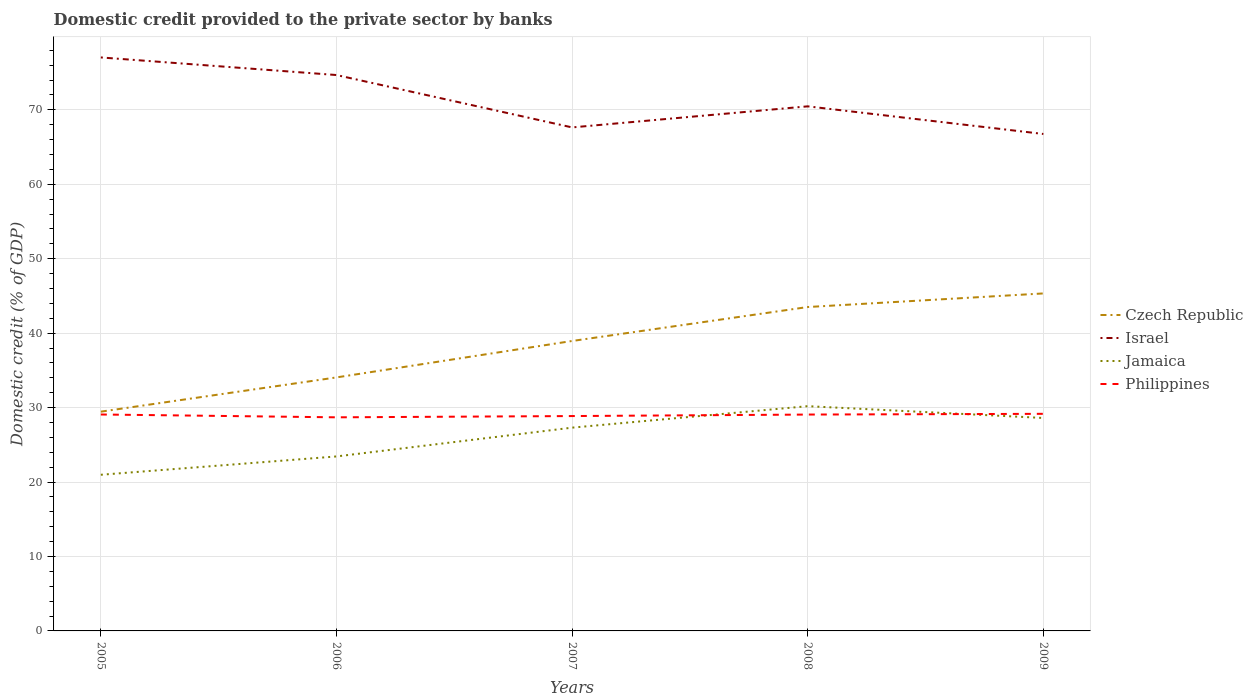Across all years, what is the maximum domestic credit provided to the private sector by banks in Philippines?
Your answer should be very brief. 28.69. What is the total domestic credit provided to the private sector by banks in Israel in the graph?
Provide a short and direct response. 2.36. What is the difference between the highest and the second highest domestic credit provided to the private sector by banks in Czech Republic?
Offer a very short reply. 15.88. What is the difference between two consecutive major ticks on the Y-axis?
Your answer should be very brief. 10. Are the values on the major ticks of Y-axis written in scientific E-notation?
Your answer should be compact. No. Does the graph contain any zero values?
Offer a terse response. No. Does the graph contain grids?
Your answer should be very brief. Yes. Where does the legend appear in the graph?
Give a very brief answer. Center right. How many legend labels are there?
Offer a very short reply. 4. What is the title of the graph?
Provide a short and direct response. Domestic credit provided to the private sector by banks. Does "Somalia" appear as one of the legend labels in the graph?
Provide a succinct answer. No. What is the label or title of the Y-axis?
Your response must be concise. Domestic credit (% of GDP). What is the Domestic credit (% of GDP) of Czech Republic in 2005?
Your answer should be very brief. 29.46. What is the Domestic credit (% of GDP) of Israel in 2005?
Make the answer very short. 77.04. What is the Domestic credit (% of GDP) in Jamaica in 2005?
Offer a very short reply. 20.98. What is the Domestic credit (% of GDP) of Philippines in 2005?
Provide a succinct answer. 29.07. What is the Domestic credit (% of GDP) in Czech Republic in 2006?
Your response must be concise. 34.06. What is the Domestic credit (% of GDP) of Israel in 2006?
Keep it short and to the point. 74.67. What is the Domestic credit (% of GDP) of Jamaica in 2006?
Provide a short and direct response. 23.44. What is the Domestic credit (% of GDP) of Philippines in 2006?
Your response must be concise. 28.69. What is the Domestic credit (% of GDP) of Czech Republic in 2007?
Your response must be concise. 38.95. What is the Domestic credit (% of GDP) in Israel in 2007?
Offer a very short reply. 67.64. What is the Domestic credit (% of GDP) of Jamaica in 2007?
Ensure brevity in your answer.  27.31. What is the Domestic credit (% of GDP) in Philippines in 2007?
Offer a very short reply. 28.86. What is the Domestic credit (% of GDP) in Czech Republic in 2008?
Provide a short and direct response. 43.51. What is the Domestic credit (% of GDP) in Israel in 2008?
Offer a terse response. 70.47. What is the Domestic credit (% of GDP) of Jamaica in 2008?
Provide a succinct answer. 30.19. What is the Domestic credit (% of GDP) of Philippines in 2008?
Offer a very short reply. 29.06. What is the Domestic credit (% of GDP) in Czech Republic in 2009?
Your answer should be very brief. 45.34. What is the Domestic credit (% of GDP) of Israel in 2009?
Your response must be concise. 66.76. What is the Domestic credit (% of GDP) in Jamaica in 2009?
Your response must be concise. 28.61. What is the Domestic credit (% of GDP) of Philippines in 2009?
Your answer should be compact. 29.16. Across all years, what is the maximum Domestic credit (% of GDP) in Czech Republic?
Your answer should be compact. 45.34. Across all years, what is the maximum Domestic credit (% of GDP) in Israel?
Make the answer very short. 77.04. Across all years, what is the maximum Domestic credit (% of GDP) of Jamaica?
Offer a very short reply. 30.19. Across all years, what is the maximum Domestic credit (% of GDP) in Philippines?
Provide a short and direct response. 29.16. Across all years, what is the minimum Domestic credit (% of GDP) of Czech Republic?
Ensure brevity in your answer.  29.46. Across all years, what is the minimum Domestic credit (% of GDP) in Israel?
Your response must be concise. 66.76. Across all years, what is the minimum Domestic credit (% of GDP) of Jamaica?
Your response must be concise. 20.98. Across all years, what is the minimum Domestic credit (% of GDP) in Philippines?
Provide a succinct answer. 28.69. What is the total Domestic credit (% of GDP) of Czech Republic in the graph?
Offer a terse response. 191.31. What is the total Domestic credit (% of GDP) in Israel in the graph?
Keep it short and to the point. 356.58. What is the total Domestic credit (% of GDP) in Jamaica in the graph?
Ensure brevity in your answer.  130.52. What is the total Domestic credit (% of GDP) of Philippines in the graph?
Give a very brief answer. 144.86. What is the difference between the Domestic credit (% of GDP) of Czech Republic in 2005 and that in 2006?
Your response must be concise. -4.6. What is the difference between the Domestic credit (% of GDP) of Israel in 2005 and that in 2006?
Make the answer very short. 2.36. What is the difference between the Domestic credit (% of GDP) of Jamaica in 2005 and that in 2006?
Make the answer very short. -2.46. What is the difference between the Domestic credit (% of GDP) in Philippines in 2005 and that in 2006?
Your response must be concise. 0.38. What is the difference between the Domestic credit (% of GDP) of Czech Republic in 2005 and that in 2007?
Offer a terse response. -9.49. What is the difference between the Domestic credit (% of GDP) in Israel in 2005 and that in 2007?
Offer a very short reply. 9.4. What is the difference between the Domestic credit (% of GDP) of Jamaica in 2005 and that in 2007?
Offer a terse response. -6.33. What is the difference between the Domestic credit (% of GDP) in Philippines in 2005 and that in 2007?
Give a very brief answer. 0.21. What is the difference between the Domestic credit (% of GDP) in Czech Republic in 2005 and that in 2008?
Provide a short and direct response. -14.05. What is the difference between the Domestic credit (% of GDP) of Israel in 2005 and that in 2008?
Offer a terse response. 6.57. What is the difference between the Domestic credit (% of GDP) in Jamaica in 2005 and that in 2008?
Make the answer very short. -9.21. What is the difference between the Domestic credit (% of GDP) of Philippines in 2005 and that in 2008?
Offer a very short reply. 0.01. What is the difference between the Domestic credit (% of GDP) in Czech Republic in 2005 and that in 2009?
Provide a succinct answer. -15.88. What is the difference between the Domestic credit (% of GDP) in Israel in 2005 and that in 2009?
Provide a short and direct response. 10.28. What is the difference between the Domestic credit (% of GDP) of Jamaica in 2005 and that in 2009?
Provide a short and direct response. -7.63. What is the difference between the Domestic credit (% of GDP) of Philippines in 2005 and that in 2009?
Your answer should be compact. -0.09. What is the difference between the Domestic credit (% of GDP) in Czech Republic in 2006 and that in 2007?
Provide a short and direct response. -4.89. What is the difference between the Domestic credit (% of GDP) in Israel in 2006 and that in 2007?
Offer a very short reply. 7.04. What is the difference between the Domestic credit (% of GDP) in Jamaica in 2006 and that in 2007?
Provide a succinct answer. -3.87. What is the difference between the Domestic credit (% of GDP) of Philippines in 2006 and that in 2007?
Ensure brevity in your answer.  -0.17. What is the difference between the Domestic credit (% of GDP) in Czech Republic in 2006 and that in 2008?
Keep it short and to the point. -9.45. What is the difference between the Domestic credit (% of GDP) in Israel in 2006 and that in 2008?
Provide a succinct answer. 4.21. What is the difference between the Domestic credit (% of GDP) of Jamaica in 2006 and that in 2008?
Provide a short and direct response. -6.75. What is the difference between the Domestic credit (% of GDP) of Philippines in 2006 and that in 2008?
Give a very brief answer. -0.37. What is the difference between the Domestic credit (% of GDP) in Czech Republic in 2006 and that in 2009?
Provide a short and direct response. -11.28. What is the difference between the Domestic credit (% of GDP) of Israel in 2006 and that in 2009?
Offer a very short reply. 7.92. What is the difference between the Domestic credit (% of GDP) of Jamaica in 2006 and that in 2009?
Ensure brevity in your answer.  -5.17. What is the difference between the Domestic credit (% of GDP) of Philippines in 2006 and that in 2009?
Offer a terse response. -0.47. What is the difference between the Domestic credit (% of GDP) in Czech Republic in 2007 and that in 2008?
Offer a terse response. -4.56. What is the difference between the Domestic credit (% of GDP) in Israel in 2007 and that in 2008?
Provide a succinct answer. -2.83. What is the difference between the Domestic credit (% of GDP) in Jamaica in 2007 and that in 2008?
Make the answer very short. -2.88. What is the difference between the Domestic credit (% of GDP) in Philippines in 2007 and that in 2008?
Ensure brevity in your answer.  -0.2. What is the difference between the Domestic credit (% of GDP) of Czech Republic in 2007 and that in 2009?
Offer a terse response. -6.39. What is the difference between the Domestic credit (% of GDP) in Israel in 2007 and that in 2009?
Offer a terse response. 0.88. What is the difference between the Domestic credit (% of GDP) of Philippines in 2007 and that in 2009?
Give a very brief answer. -0.3. What is the difference between the Domestic credit (% of GDP) in Czech Republic in 2008 and that in 2009?
Provide a succinct answer. -1.83. What is the difference between the Domestic credit (% of GDP) of Israel in 2008 and that in 2009?
Ensure brevity in your answer.  3.71. What is the difference between the Domestic credit (% of GDP) in Jamaica in 2008 and that in 2009?
Give a very brief answer. 1.58. What is the difference between the Domestic credit (% of GDP) in Philippines in 2008 and that in 2009?
Make the answer very short. -0.1. What is the difference between the Domestic credit (% of GDP) in Czech Republic in 2005 and the Domestic credit (% of GDP) in Israel in 2006?
Your answer should be very brief. -45.22. What is the difference between the Domestic credit (% of GDP) of Czech Republic in 2005 and the Domestic credit (% of GDP) of Jamaica in 2006?
Provide a succinct answer. 6.02. What is the difference between the Domestic credit (% of GDP) in Czech Republic in 2005 and the Domestic credit (% of GDP) in Philippines in 2006?
Your response must be concise. 0.76. What is the difference between the Domestic credit (% of GDP) of Israel in 2005 and the Domestic credit (% of GDP) of Jamaica in 2006?
Offer a very short reply. 53.6. What is the difference between the Domestic credit (% of GDP) of Israel in 2005 and the Domestic credit (% of GDP) of Philippines in 2006?
Your answer should be compact. 48.34. What is the difference between the Domestic credit (% of GDP) in Jamaica in 2005 and the Domestic credit (% of GDP) in Philippines in 2006?
Provide a succinct answer. -7.72. What is the difference between the Domestic credit (% of GDP) in Czech Republic in 2005 and the Domestic credit (% of GDP) in Israel in 2007?
Your answer should be compact. -38.18. What is the difference between the Domestic credit (% of GDP) of Czech Republic in 2005 and the Domestic credit (% of GDP) of Jamaica in 2007?
Your answer should be compact. 2.15. What is the difference between the Domestic credit (% of GDP) of Czech Republic in 2005 and the Domestic credit (% of GDP) of Philippines in 2007?
Provide a short and direct response. 0.59. What is the difference between the Domestic credit (% of GDP) in Israel in 2005 and the Domestic credit (% of GDP) in Jamaica in 2007?
Offer a terse response. 49.73. What is the difference between the Domestic credit (% of GDP) in Israel in 2005 and the Domestic credit (% of GDP) in Philippines in 2007?
Give a very brief answer. 48.17. What is the difference between the Domestic credit (% of GDP) in Jamaica in 2005 and the Domestic credit (% of GDP) in Philippines in 2007?
Ensure brevity in your answer.  -7.89. What is the difference between the Domestic credit (% of GDP) of Czech Republic in 2005 and the Domestic credit (% of GDP) of Israel in 2008?
Offer a very short reply. -41.01. What is the difference between the Domestic credit (% of GDP) of Czech Republic in 2005 and the Domestic credit (% of GDP) of Jamaica in 2008?
Provide a succinct answer. -0.74. What is the difference between the Domestic credit (% of GDP) of Czech Republic in 2005 and the Domestic credit (% of GDP) of Philippines in 2008?
Your answer should be very brief. 0.39. What is the difference between the Domestic credit (% of GDP) in Israel in 2005 and the Domestic credit (% of GDP) in Jamaica in 2008?
Make the answer very short. 46.85. What is the difference between the Domestic credit (% of GDP) in Israel in 2005 and the Domestic credit (% of GDP) in Philippines in 2008?
Keep it short and to the point. 47.97. What is the difference between the Domestic credit (% of GDP) of Jamaica in 2005 and the Domestic credit (% of GDP) of Philippines in 2008?
Provide a short and direct response. -8.09. What is the difference between the Domestic credit (% of GDP) of Czech Republic in 2005 and the Domestic credit (% of GDP) of Israel in 2009?
Ensure brevity in your answer.  -37.3. What is the difference between the Domestic credit (% of GDP) in Czech Republic in 2005 and the Domestic credit (% of GDP) in Jamaica in 2009?
Offer a terse response. 0.85. What is the difference between the Domestic credit (% of GDP) in Czech Republic in 2005 and the Domestic credit (% of GDP) in Philippines in 2009?
Your response must be concise. 0.29. What is the difference between the Domestic credit (% of GDP) of Israel in 2005 and the Domestic credit (% of GDP) of Jamaica in 2009?
Give a very brief answer. 48.43. What is the difference between the Domestic credit (% of GDP) in Israel in 2005 and the Domestic credit (% of GDP) in Philippines in 2009?
Offer a very short reply. 47.88. What is the difference between the Domestic credit (% of GDP) in Jamaica in 2005 and the Domestic credit (% of GDP) in Philippines in 2009?
Make the answer very short. -8.18. What is the difference between the Domestic credit (% of GDP) of Czech Republic in 2006 and the Domestic credit (% of GDP) of Israel in 2007?
Make the answer very short. -33.58. What is the difference between the Domestic credit (% of GDP) of Czech Republic in 2006 and the Domestic credit (% of GDP) of Jamaica in 2007?
Provide a succinct answer. 6.75. What is the difference between the Domestic credit (% of GDP) in Czech Republic in 2006 and the Domestic credit (% of GDP) in Philippines in 2007?
Make the answer very short. 5.19. What is the difference between the Domestic credit (% of GDP) in Israel in 2006 and the Domestic credit (% of GDP) in Jamaica in 2007?
Offer a terse response. 47.37. What is the difference between the Domestic credit (% of GDP) in Israel in 2006 and the Domestic credit (% of GDP) in Philippines in 2007?
Give a very brief answer. 45.81. What is the difference between the Domestic credit (% of GDP) of Jamaica in 2006 and the Domestic credit (% of GDP) of Philippines in 2007?
Provide a short and direct response. -5.42. What is the difference between the Domestic credit (% of GDP) of Czech Republic in 2006 and the Domestic credit (% of GDP) of Israel in 2008?
Your answer should be very brief. -36.41. What is the difference between the Domestic credit (% of GDP) in Czech Republic in 2006 and the Domestic credit (% of GDP) in Jamaica in 2008?
Give a very brief answer. 3.86. What is the difference between the Domestic credit (% of GDP) of Czech Republic in 2006 and the Domestic credit (% of GDP) of Philippines in 2008?
Your answer should be very brief. 4.99. What is the difference between the Domestic credit (% of GDP) in Israel in 2006 and the Domestic credit (% of GDP) in Jamaica in 2008?
Provide a succinct answer. 44.48. What is the difference between the Domestic credit (% of GDP) of Israel in 2006 and the Domestic credit (% of GDP) of Philippines in 2008?
Offer a very short reply. 45.61. What is the difference between the Domestic credit (% of GDP) in Jamaica in 2006 and the Domestic credit (% of GDP) in Philippines in 2008?
Offer a terse response. -5.63. What is the difference between the Domestic credit (% of GDP) of Czech Republic in 2006 and the Domestic credit (% of GDP) of Israel in 2009?
Ensure brevity in your answer.  -32.7. What is the difference between the Domestic credit (% of GDP) of Czech Republic in 2006 and the Domestic credit (% of GDP) of Jamaica in 2009?
Provide a short and direct response. 5.45. What is the difference between the Domestic credit (% of GDP) in Czech Republic in 2006 and the Domestic credit (% of GDP) in Philippines in 2009?
Make the answer very short. 4.89. What is the difference between the Domestic credit (% of GDP) of Israel in 2006 and the Domestic credit (% of GDP) of Jamaica in 2009?
Your answer should be very brief. 46.07. What is the difference between the Domestic credit (% of GDP) of Israel in 2006 and the Domestic credit (% of GDP) of Philippines in 2009?
Your answer should be very brief. 45.51. What is the difference between the Domestic credit (% of GDP) of Jamaica in 2006 and the Domestic credit (% of GDP) of Philippines in 2009?
Keep it short and to the point. -5.72. What is the difference between the Domestic credit (% of GDP) of Czech Republic in 2007 and the Domestic credit (% of GDP) of Israel in 2008?
Provide a succinct answer. -31.52. What is the difference between the Domestic credit (% of GDP) of Czech Republic in 2007 and the Domestic credit (% of GDP) of Jamaica in 2008?
Provide a short and direct response. 8.76. What is the difference between the Domestic credit (% of GDP) of Czech Republic in 2007 and the Domestic credit (% of GDP) of Philippines in 2008?
Give a very brief answer. 9.88. What is the difference between the Domestic credit (% of GDP) in Israel in 2007 and the Domestic credit (% of GDP) in Jamaica in 2008?
Offer a very short reply. 37.45. What is the difference between the Domestic credit (% of GDP) of Israel in 2007 and the Domestic credit (% of GDP) of Philippines in 2008?
Give a very brief answer. 38.57. What is the difference between the Domestic credit (% of GDP) in Jamaica in 2007 and the Domestic credit (% of GDP) in Philippines in 2008?
Make the answer very short. -1.76. What is the difference between the Domestic credit (% of GDP) of Czech Republic in 2007 and the Domestic credit (% of GDP) of Israel in 2009?
Provide a succinct answer. -27.81. What is the difference between the Domestic credit (% of GDP) of Czech Republic in 2007 and the Domestic credit (% of GDP) of Jamaica in 2009?
Your answer should be compact. 10.34. What is the difference between the Domestic credit (% of GDP) in Czech Republic in 2007 and the Domestic credit (% of GDP) in Philippines in 2009?
Give a very brief answer. 9.79. What is the difference between the Domestic credit (% of GDP) in Israel in 2007 and the Domestic credit (% of GDP) in Jamaica in 2009?
Ensure brevity in your answer.  39.03. What is the difference between the Domestic credit (% of GDP) in Israel in 2007 and the Domestic credit (% of GDP) in Philippines in 2009?
Provide a short and direct response. 38.48. What is the difference between the Domestic credit (% of GDP) in Jamaica in 2007 and the Domestic credit (% of GDP) in Philippines in 2009?
Keep it short and to the point. -1.86. What is the difference between the Domestic credit (% of GDP) of Czech Republic in 2008 and the Domestic credit (% of GDP) of Israel in 2009?
Offer a very short reply. -23.25. What is the difference between the Domestic credit (% of GDP) in Czech Republic in 2008 and the Domestic credit (% of GDP) in Jamaica in 2009?
Your answer should be compact. 14.9. What is the difference between the Domestic credit (% of GDP) of Czech Republic in 2008 and the Domestic credit (% of GDP) of Philippines in 2009?
Give a very brief answer. 14.35. What is the difference between the Domestic credit (% of GDP) in Israel in 2008 and the Domestic credit (% of GDP) in Jamaica in 2009?
Provide a succinct answer. 41.86. What is the difference between the Domestic credit (% of GDP) in Israel in 2008 and the Domestic credit (% of GDP) in Philippines in 2009?
Ensure brevity in your answer.  41.31. What is the difference between the Domestic credit (% of GDP) of Jamaica in 2008 and the Domestic credit (% of GDP) of Philippines in 2009?
Your answer should be very brief. 1.03. What is the average Domestic credit (% of GDP) of Czech Republic per year?
Your answer should be compact. 38.26. What is the average Domestic credit (% of GDP) of Israel per year?
Offer a terse response. 71.32. What is the average Domestic credit (% of GDP) of Jamaica per year?
Provide a short and direct response. 26.1. What is the average Domestic credit (% of GDP) in Philippines per year?
Give a very brief answer. 28.97. In the year 2005, what is the difference between the Domestic credit (% of GDP) of Czech Republic and Domestic credit (% of GDP) of Israel?
Provide a short and direct response. -47.58. In the year 2005, what is the difference between the Domestic credit (% of GDP) of Czech Republic and Domestic credit (% of GDP) of Jamaica?
Your answer should be very brief. 8.48. In the year 2005, what is the difference between the Domestic credit (% of GDP) of Czech Republic and Domestic credit (% of GDP) of Philippines?
Provide a short and direct response. 0.38. In the year 2005, what is the difference between the Domestic credit (% of GDP) in Israel and Domestic credit (% of GDP) in Jamaica?
Make the answer very short. 56.06. In the year 2005, what is the difference between the Domestic credit (% of GDP) in Israel and Domestic credit (% of GDP) in Philippines?
Provide a short and direct response. 47.96. In the year 2005, what is the difference between the Domestic credit (% of GDP) in Jamaica and Domestic credit (% of GDP) in Philippines?
Offer a very short reply. -8.1. In the year 2006, what is the difference between the Domestic credit (% of GDP) of Czech Republic and Domestic credit (% of GDP) of Israel?
Ensure brevity in your answer.  -40.62. In the year 2006, what is the difference between the Domestic credit (% of GDP) of Czech Republic and Domestic credit (% of GDP) of Jamaica?
Offer a very short reply. 10.62. In the year 2006, what is the difference between the Domestic credit (% of GDP) in Czech Republic and Domestic credit (% of GDP) in Philippines?
Give a very brief answer. 5.36. In the year 2006, what is the difference between the Domestic credit (% of GDP) in Israel and Domestic credit (% of GDP) in Jamaica?
Your response must be concise. 51.24. In the year 2006, what is the difference between the Domestic credit (% of GDP) in Israel and Domestic credit (% of GDP) in Philippines?
Provide a short and direct response. 45.98. In the year 2006, what is the difference between the Domestic credit (% of GDP) in Jamaica and Domestic credit (% of GDP) in Philippines?
Offer a very short reply. -5.25. In the year 2007, what is the difference between the Domestic credit (% of GDP) in Czech Republic and Domestic credit (% of GDP) in Israel?
Provide a succinct answer. -28.69. In the year 2007, what is the difference between the Domestic credit (% of GDP) of Czech Republic and Domestic credit (% of GDP) of Jamaica?
Your response must be concise. 11.64. In the year 2007, what is the difference between the Domestic credit (% of GDP) in Czech Republic and Domestic credit (% of GDP) in Philippines?
Provide a succinct answer. 10.08. In the year 2007, what is the difference between the Domestic credit (% of GDP) in Israel and Domestic credit (% of GDP) in Jamaica?
Keep it short and to the point. 40.33. In the year 2007, what is the difference between the Domestic credit (% of GDP) in Israel and Domestic credit (% of GDP) in Philippines?
Provide a short and direct response. 38.77. In the year 2007, what is the difference between the Domestic credit (% of GDP) of Jamaica and Domestic credit (% of GDP) of Philippines?
Your answer should be compact. -1.56. In the year 2008, what is the difference between the Domestic credit (% of GDP) in Czech Republic and Domestic credit (% of GDP) in Israel?
Keep it short and to the point. -26.96. In the year 2008, what is the difference between the Domestic credit (% of GDP) in Czech Republic and Domestic credit (% of GDP) in Jamaica?
Provide a short and direct response. 13.32. In the year 2008, what is the difference between the Domestic credit (% of GDP) in Czech Republic and Domestic credit (% of GDP) in Philippines?
Provide a succinct answer. 14.45. In the year 2008, what is the difference between the Domestic credit (% of GDP) in Israel and Domestic credit (% of GDP) in Jamaica?
Your response must be concise. 40.28. In the year 2008, what is the difference between the Domestic credit (% of GDP) in Israel and Domestic credit (% of GDP) in Philippines?
Keep it short and to the point. 41.4. In the year 2008, what is the difference between the Domestic credit (% of GDP) in Jamaica and Domestic credit (% of GDP) in Philippines?
Ensure brevity in your answer.  1.13. In the year 2009, what is the difference between the Domestic credit (% of GDP) in Czech Republic and Domestic credit (% of GDP) in Israel?
Ensure brevity in your answer.  -21.42. In the year 2009, what is the difference between the Domestic credit (% of GDP) in Czech Republic and Domestic credit (% of GDP) in Jamaica?
Provide a succinct answer. 16.73. In the year 2009, what is the difference between the Domestic credit (% of GDP) of Czech Republic and Domestic credit (% of GDP) of Philippines?
Provide a short and direct response. 16.17. In the year 2009, what is the difference between the Domestic credit (% of GDP) of Israel and Domestic credit (% of GDP) of Jamaica?
Your answer should be compact. 38.15. In the year 2009, what is the difference between the Domestic credit (% of GDP) of Israel and Domestic credit (% of GDP) of Philippines?
Your answer should be very brief. 37.59. In the year 2009, what is the difference between the Domestic credit (% of GDP) of Jamaica and Domestic credit (% of GDP) of Philippines?
Provide a succinct answer. -0.56. What is the ratio of the Domestic credit (% of GDP) of Czech Republic in 2005 to that in 2006?
Offer a terse response. 0.86. What is the ratio of the Domestic credit (% of GDP) of Israel in 2005 to that in 2006?
Give a very brief answer. 1.03. What is the ratio of the Domestic credit (% of GDP) in Jamaica in 2005 to that in 2006?
Your answer should be compact. 0.9. What is the ratio of the Domestic credit (% of GDP) of Philippines in 2005 to that in 2006?
Ensure brevity in your answer.  1.01. What is the ratio of the Domestic credit (% of GDP) of Czech Republic in 2005 to that in 2007?
Provide a short and direct response. 0.76. What is the ratio of the Domestic credit (% of GDP) in Israel in 2005 to that in 2007?
Provide a succinct answer. 1.14. What is the ratio of the Domestic credit (% of GDP) of Jamaica in 2005 to that in 2007?
Give a very brief answer. 0.77. What is the ratio of the Domestic credit (% of GDP) in Philippines in 2005 to that in 2007?
Your answer should be compact. 1.01. What is the ratio of the Domestic credit (% of GDP) of Czech Republic in 2005 to that in 2008?
Offer a terse response. 0.68. What is the ratio of the Domestic credit (% of GDP) of Israel in 2005 to that in 2008?
Your response must be concise. 1.09. What is the ratio of the Domestic credit (% of GDP) in Jamaica in 2005 to that in 2008?
Offer a very short reply. 0.69. What is the ratio of the Domestic credit (% of GDP) in Philippines in 2005 to that in 2008?
Your answer should be compact. 1. What is the ratio of the Domestic credit (% of GDP) in Czech Republic in 2005 to that in 2009?
Give a very brief answer. 0.65. What is the ratio of the Domestic credit (% of GDP) in Israel in 2005 to that in 2009?
Provide a succinct answer. 1.15. What is the ratio of the Domestic credit (% of GDP) of Jamaica in 2005 to that in 2009?
Provide a succinct answer. 0.73. What is the ratio of the Domestic credit (% of GDP) of Czech Republic in 2006 to that in 2007?
Your answer should be very brief. 0.87. What is the ratio of the Domestic credit (% of GDP) in Israel in 2006 to that in 2007?
Provide a short and direct response. 1.1. What is the ratio of the Domestic credit (% of GDP) in Jamaica in 2006 to that in 2007?
Your answer should be compact. 0.86. What is the ratio of the Domestic credit (% of GDP) of Philippines in 2006 to that in 2007?
Your response must be concise. 0.99. What is the ratio of the Domestic credit (% of GDP) in Czech Republic in 2006 to that in 2008?
Your response must be concise. 0.78. What is the ratio of the Domestic credit (% of GDP) in Israel in 2006 to that in 2008?
Ensure brevity in your answer.  1.06. What is the ratio of the Domestic credit (% of GDP) in Jamaica in 2006 to that in 2008?
Ensure brevity in your answer.  0.78. What is the ratio of the Domestic credit (% of GDP) of Philippines in 2006 to that in 2008?
Offer a very short reply. 0.99. What is the ratio of the Domestic credit (% of GDP) of Czech Republic in 2006 to that in 2009?
Offer a terse response. 0.75. What is the ratio of the Domestic credit (% of GDP) in Israel in 2006 to that in 2009?
Your response must be concise. 1.12. What is the ratio of the Domestic credit (% of GDP) of Jamaica in 2006 to that in 2009?
Make the answer very short. 0.82. What is the ratio of the Domestic credit (% of GDP) in Philippines in 2006 to that in 2009?
Offer a terse response. 0.98. What is the ratio of the Domestic credit (% of GDP) in Czech Republic in 2007 to that in 2008?
Keep it short and to the point. 0.9. What is the ratio of the Domestic credit (% of GDP) in Israel in 2007 to that in 2008?
Your response must be concise. 0.96. What is the ratio of the Domestic credit (% of GDP) of Jamaica in 2007 to that in 2008?
Offer a very short reply. 0.9. What is the ratio of the Domestic credit (% of GDP) in Philippines in 2007 to that in 2008?
Offer a terse response. 0.99. What is the ratio of the Domestic credit (% of GDP) of Czech Republic in 2007 to that in 2009?
Your answer should be very brief. 0.86. What is the ratio of the Domestic credit (% of GDP) of Israel in 2007 to that in 2009?
Your answer should be very brief. 1.01. What is the ratio of the Domestic credit (% of GDP) of Jamaica in 2007 to that in 2009?
Your answer should be very brief. 0.95. What is the ratio of the Domestic credit (% of GDP) of Czech Republic in 2008 to that in 2009?
Keep it short and to the point. 0.96. What is the ratio of the Domestic credit (% of GDP) in Israel in 2008 to that in 2009?
Your answer should be very brief. 1.06. What is the ratio of the Domestic credit (% of GDP) of Jamaica in 2008 to that in 2009?
Your answer should be very brief. 1.06. What is the difference between the highest and the second highest Domestic credit (% of GDP) in Czech Republic?
Your answer should be very brief. 1.83. What is the difference between the highest and the second highest Domestic credit (% of GDP) of Israel?
Provide a succinct answer. 2.36. What is the difference between the highest and the second highest Domestic credit (% of GDP) in Jamaica?
Your response must be concise. 1.58. What is the difference between the highest and the second highest Domestic credit (% of GDP) in Philippines?
Your answer should be very brief. 0.09. What is the difference between the highest and the lowest Domestic credit (% of GDP) in Czech Republic?
Your response must be concise. 15.88. What is the difference between the highest and the lowest Domestic credit (% of GDP) of Israel?
Make the answer very short. 10.28. What is the difference between the highest and the lowest Domestic credit (% of GDP) of Jamaica?
Provide a succinct answer. 9.21. What is the difference between the highest and the lowest Domestic credit (% of GDP) of Philippines?
Your answer should be very brief. 0.47. 